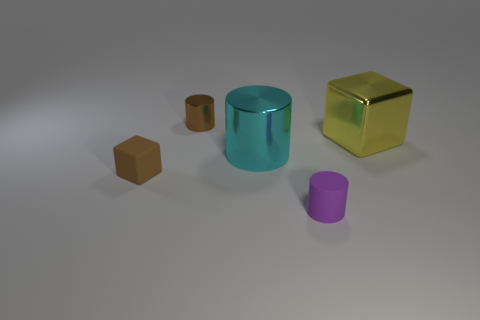Can you describe the textures visible on the surfaces of the objects? The surfaces of the objects appear smooth and somewhat reflective. The cube to the right has a glossy finish that reflects light, indicating a polished texture, while the other objects display more subdued reflections. 